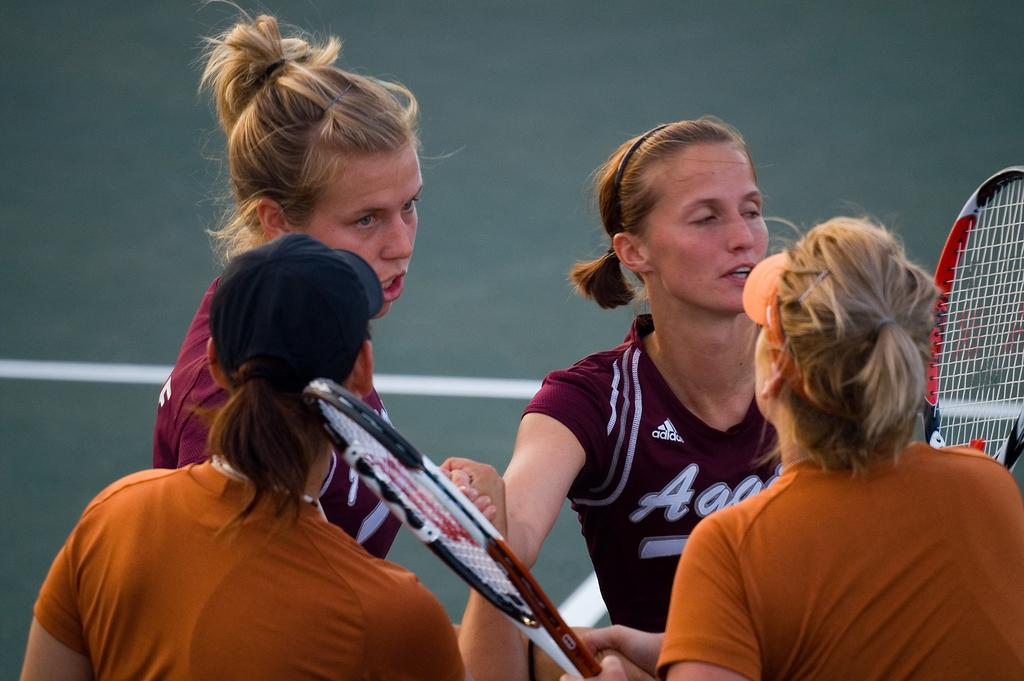How many people are in the image? There is a group of people in the image. What are the people holding in the image? The people are holding bats. What type of bean is being used to attach the screw to the brass in the image? There is no bean, screw, or brass present in the image; the people are holding bats. 